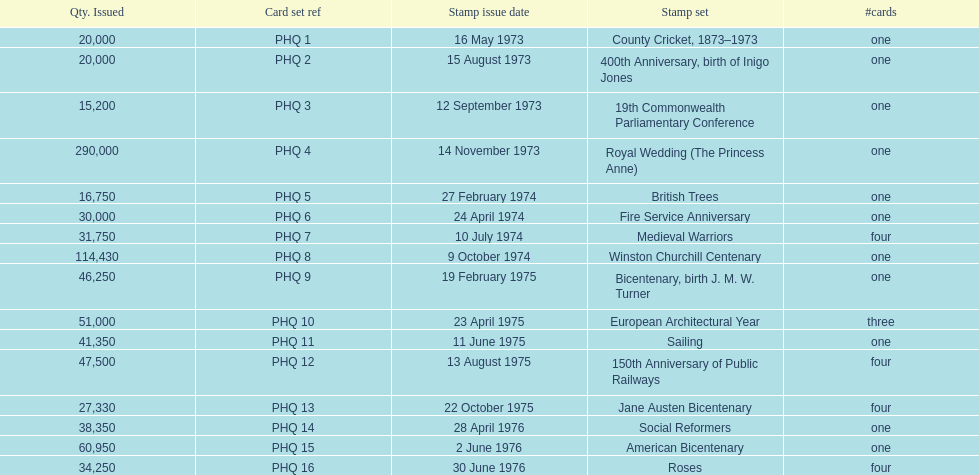How many stamp sets were released in the year 1975? 5. 